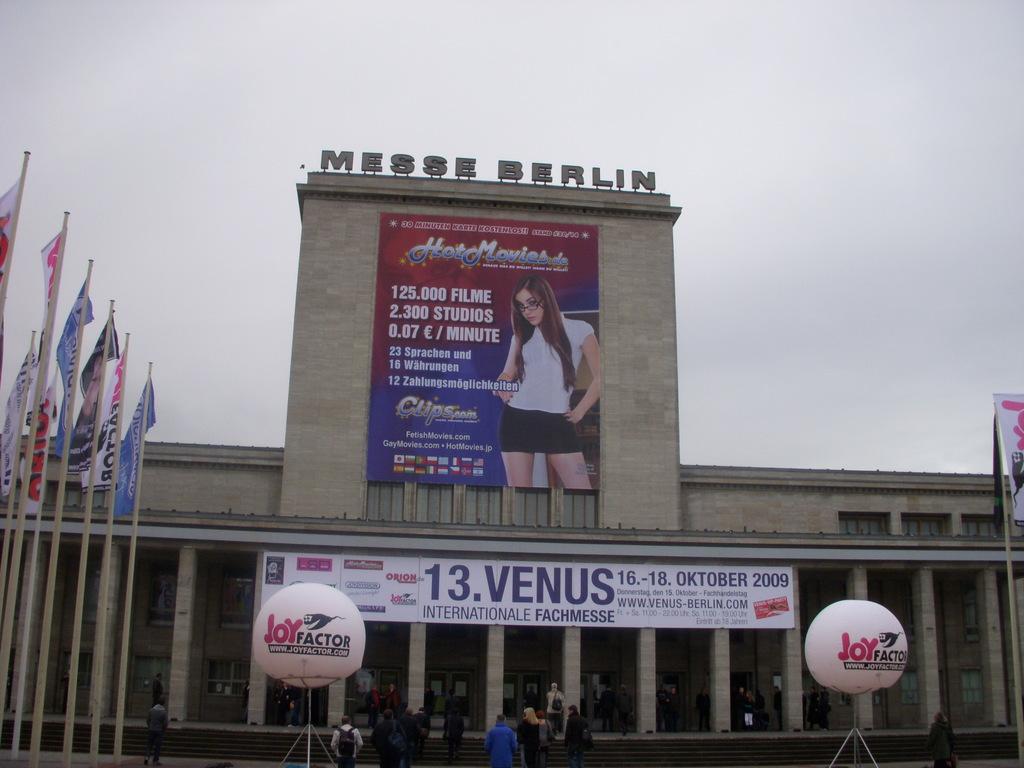What is the word in pink on the round ball?
Offer a terse response. Joy. 